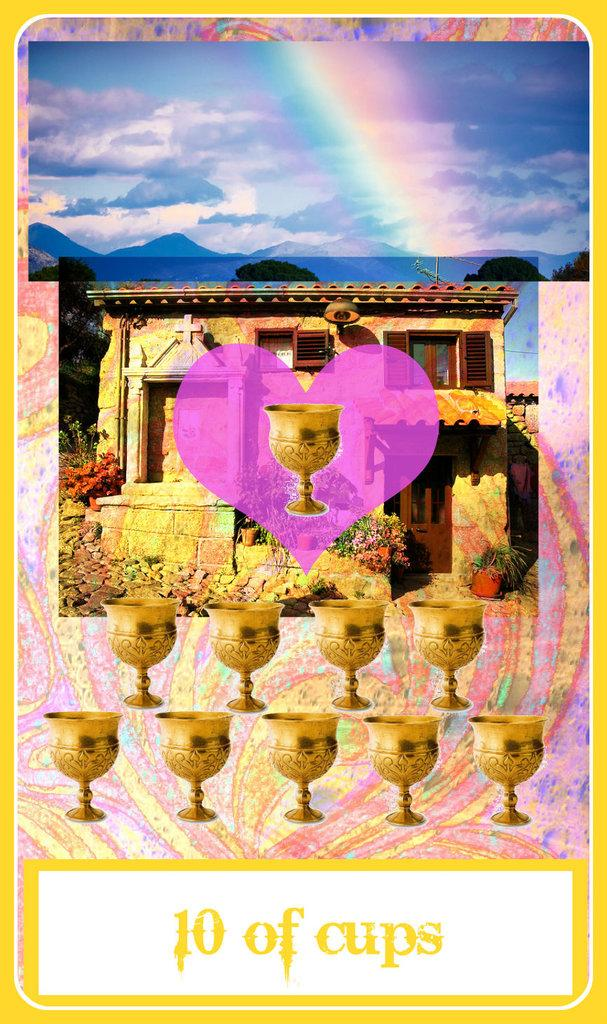<image>
Give a short and clear explanation of the subsequent image. a yellow framed poster that says '10 of cups' on it 